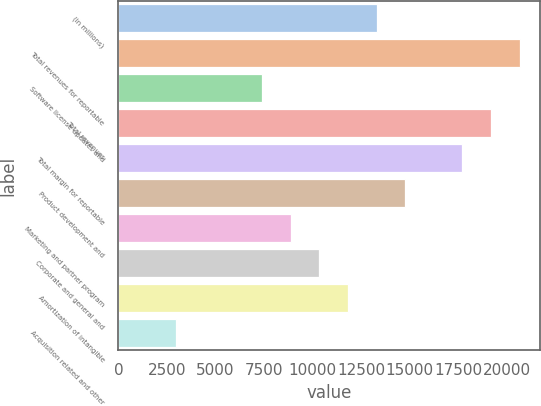Convert chart. <chart><loc_0><loc_0><loc_500><loc_500><bar_chart><fcel>(in millions)<fcel>Total revenues for reportable<fcel>Software license updates and<fcel>Total revenues<fcel>Total margin for reportable<fcel>Product development and<fcel>Marketing and partner program<fcel>Corporate and general and<fcel>Amortization of intangible<fcel>Acquisition related and other<nl><fcel>13297<fcel>20667<fcel>7401<fcel>19193<fcel>17719<fcel>14771<fcel>8875<fcel>10349<fcel>11823<fcel>2979<nl></chart> 